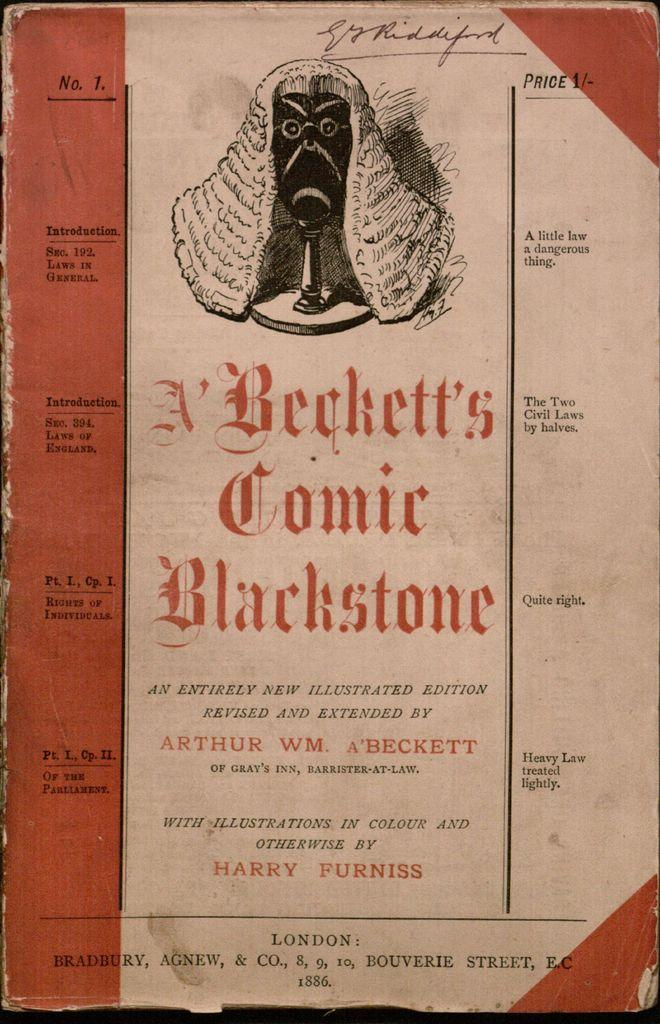Provide a one-sentence caption for the provided image. An old book by Arthur Beckett that is illustrated. 